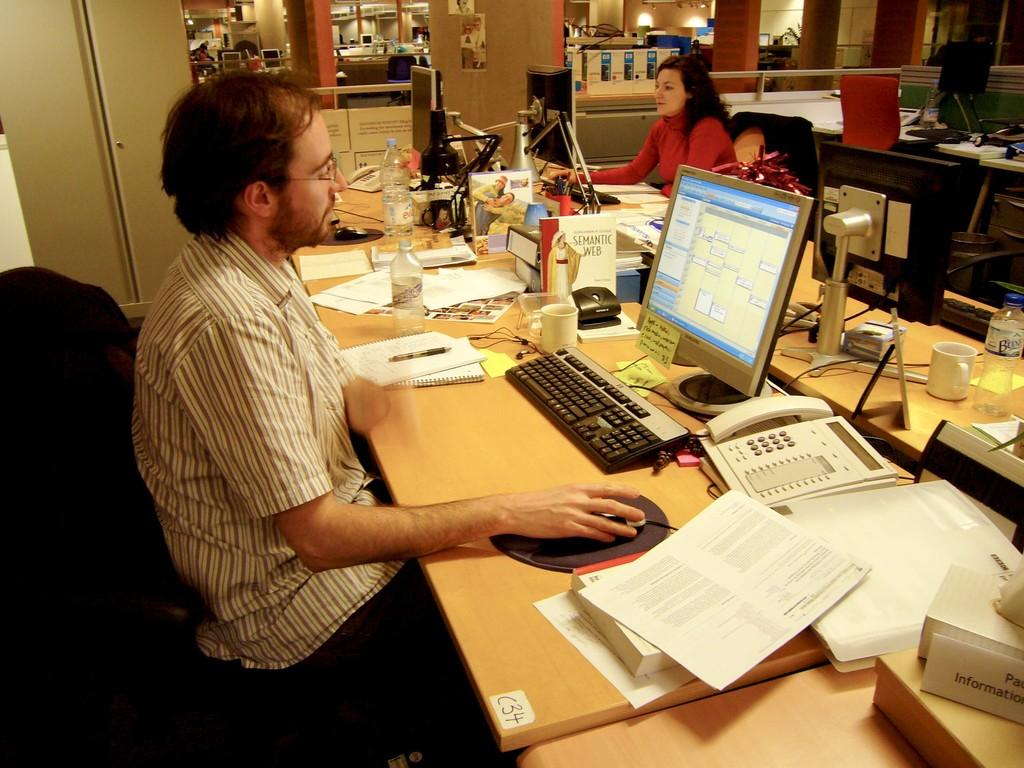<image>
Create a compact narrative representing the image presented. A man with glasses at a messy desk a sign in the lower right corner says Information. 